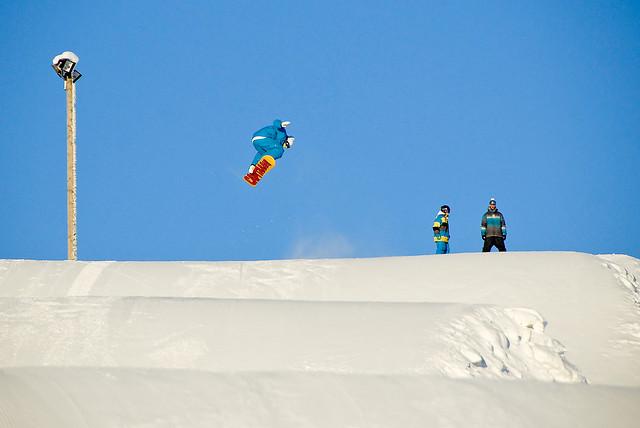Is he doing a trick?
Keep it brief. Yes. Is this a children's activity?
Keep it brief. No. Is he jumping off a slope?
Be succinct. Yes. 